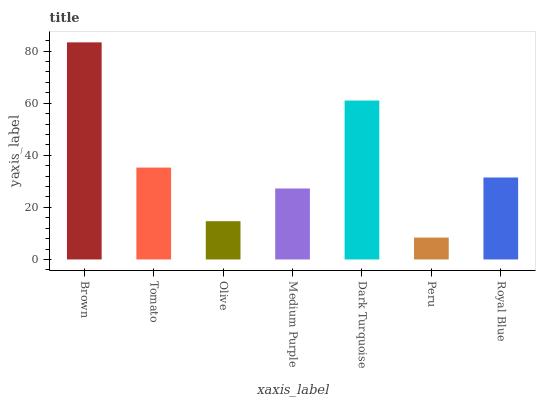Is Tomato the minimum?
Answer yes or no. No. Is Tomato the maximum?
Answer yes or no. No. Is Brown greater than Tomato?
Answer yes or no. Yes. Is Tomato less than Brown?
Answer yes or no. Yes. Is Tomato greater than Brown?
Answer yes or no. No. Is Brown less than Tomato?
Answer yes or no. No. Is Royal Blue the high median?
Answer yes or no. Yes. Is Royal Blue the low median?
Answer yes or no. Yes. Is Brown the high median?
Answer yes or no. No. Is Tomato the low median?
Answer yes or no. No. 